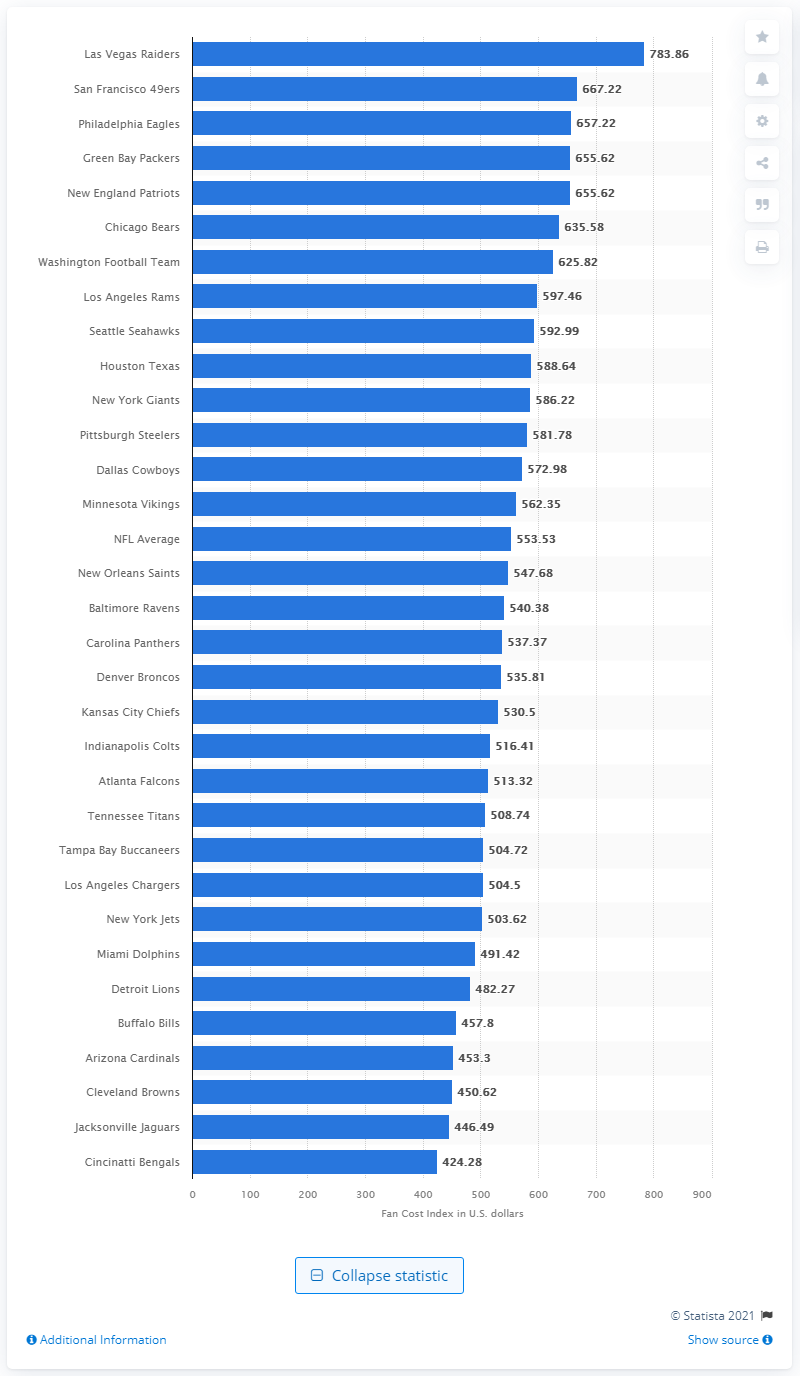Point out several critical features in this image. The average cost of attending an NFL game during the same season was $553.53. The Fan Cost Index for the Las Vegas Raiders in 2020 was approximately $783.86. 